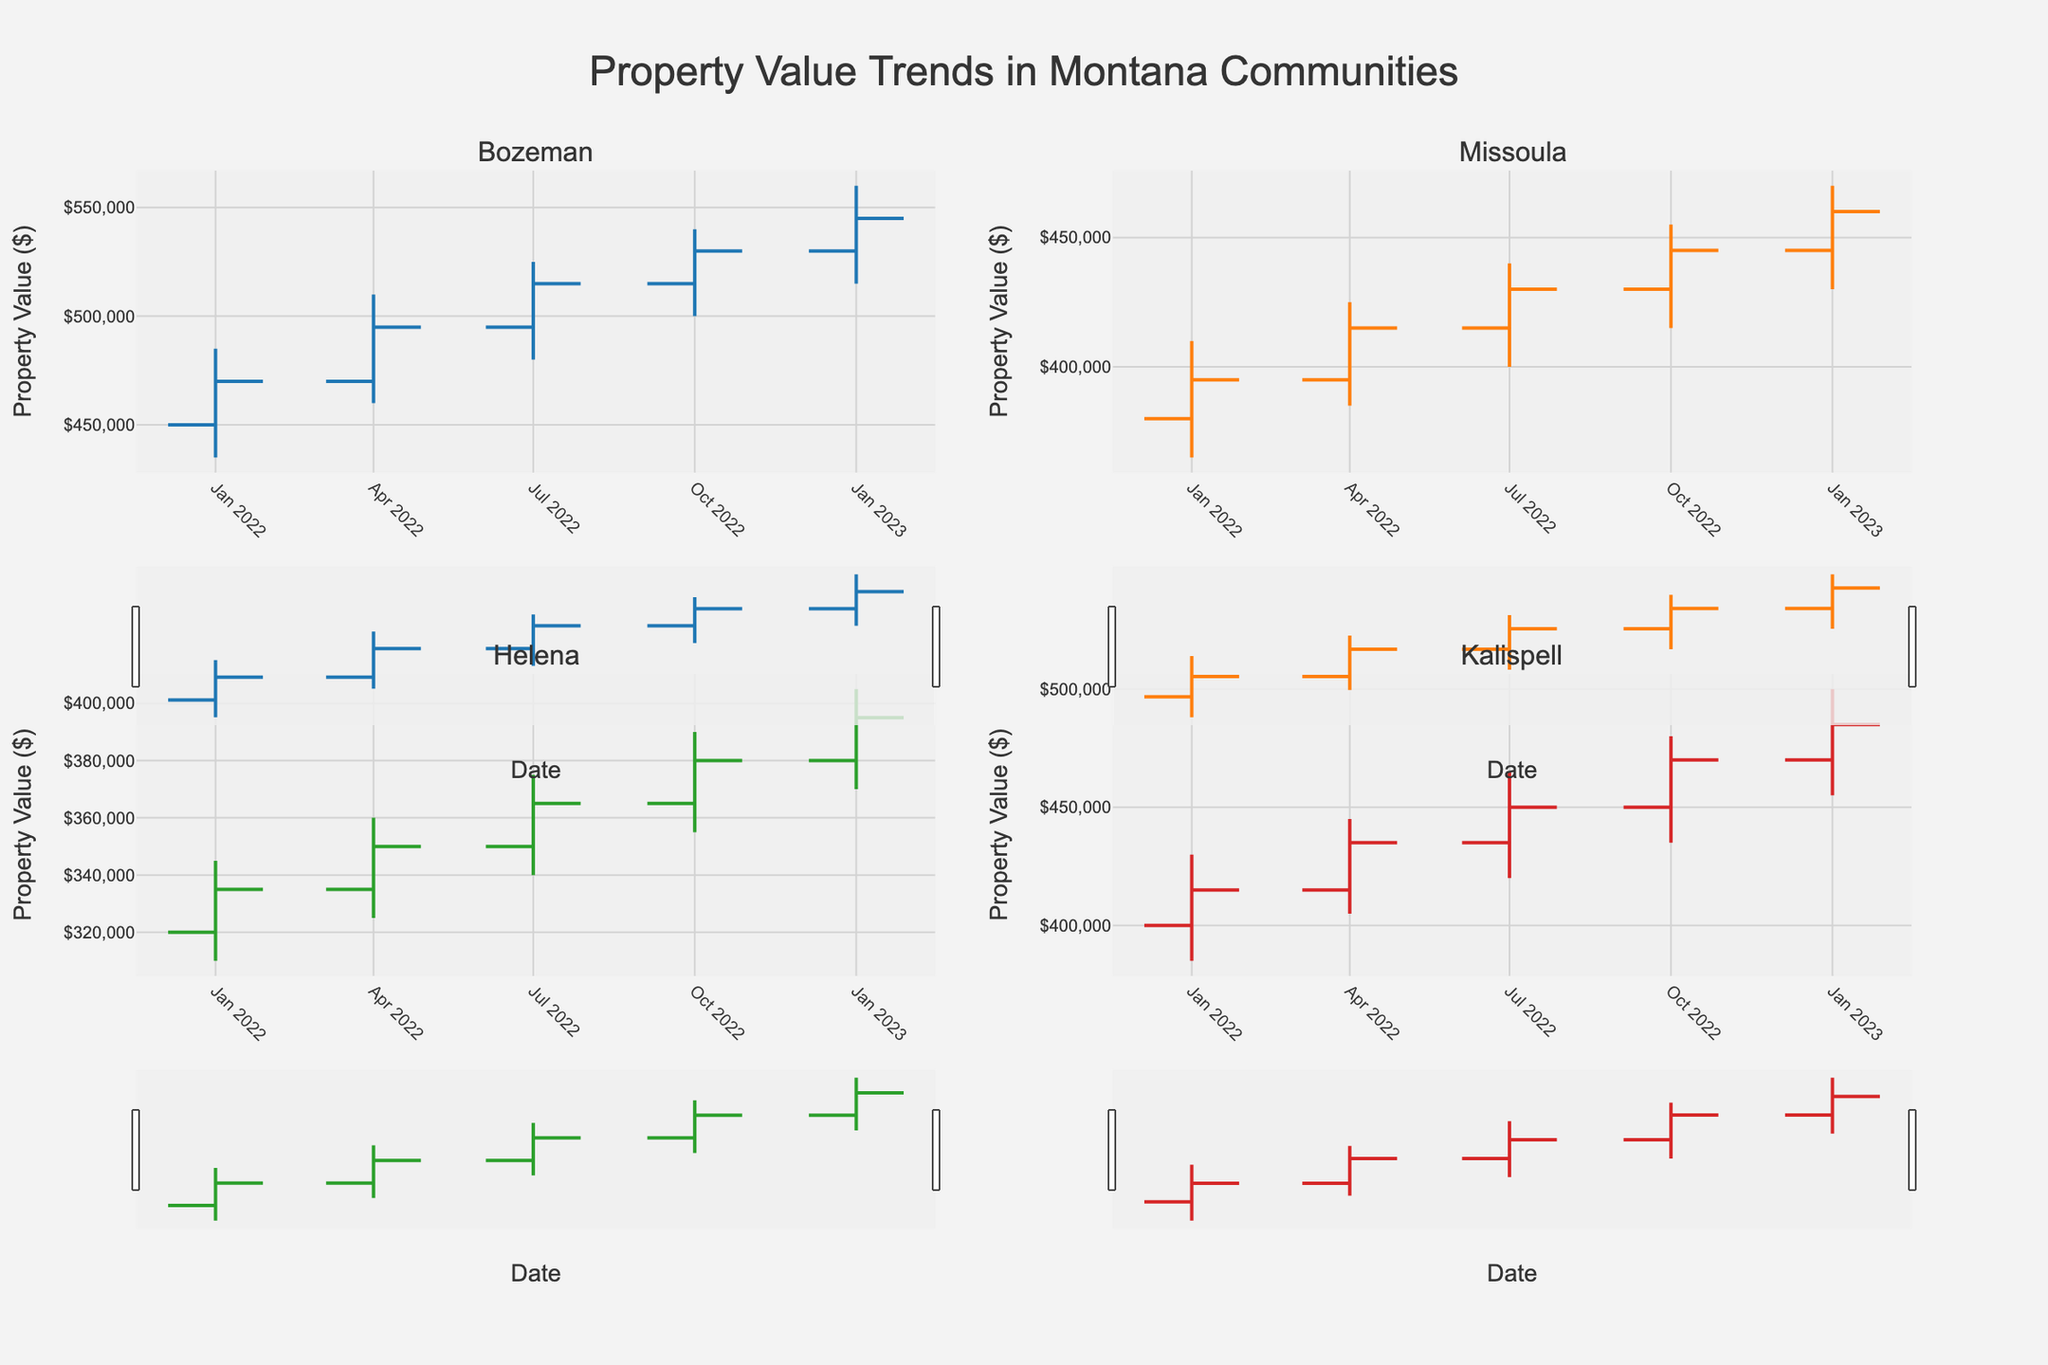What's the title of the figure? The title is typically placed at the top center of the figure. In this case, the code specifies the title as "Property Value Trends in Montana Communities".
Answer: Property Value Trends in Montana Communities What does the x-axis represent? The x-axis represents the timeline, which is specified by the "Date" column in the dataset. The date range in the figure is displayed in a monthly format from January 2022 to January 2023.
Answer: Date What is the highest closing property value in Bozeman over the time period? To find the highest closing property value, look at the "Close" values for Bozeman in the OHLC chart. The highest value reaches $545,000 in January 2023.
Answer: $545,000 Which community had the lowest opening property value in January 2022? By checking the "Open" values in January 2022 for all four communities in the OHLC chart, Helena had the lowest opening property value of $320,000.
Answer: Helena How did the property values in Missoula change from January 2022 to January 2023? To determine the change, compare the "Close" values of Missoula in January 2022 and January 2023. The values increased from $395,000 to $460,000, resulting in a change of $65,000.
Answer: Increased by $65,000 Which community shows the most consistent increase in property values throughout the year? By analyzing the OHLC charts, Bozeman shows a consistent increase in closing values each quarter. From $470,000 in January 2022 to $545,000 in January 2023, the property values steadily increased each quarter.
Answer: Bozeman In which community and quarter did the highest value spike occur? The highest value spike is determined by the largest difference between the "High" and "Low" values in a single period. In Bozeman, from January to April 2022, the values spiked from $460,000 to $510,000—a $50,000 difference.
Answer: Bozeman, January to April 2022 What was the average closing value in Kalispell over the recorded period? Average closing value is calculated by summing the closing values for Kalispell and dividing by the number of periods. The sum is $415,000 + $435,000 + $450,000 + $470,000 + $485,000 = $2,255,000. Dividing by 5 gives an average of $451,000.
Answer: $451,000 Between Helena and Kalispell, which community had higher property values in October 2022? By comparing the closing values in October 2022, Kalispell's property value was $470,000, while Helena's was $380,000. Thus, Kalispell had higher property values.
Answer: Kalispell 